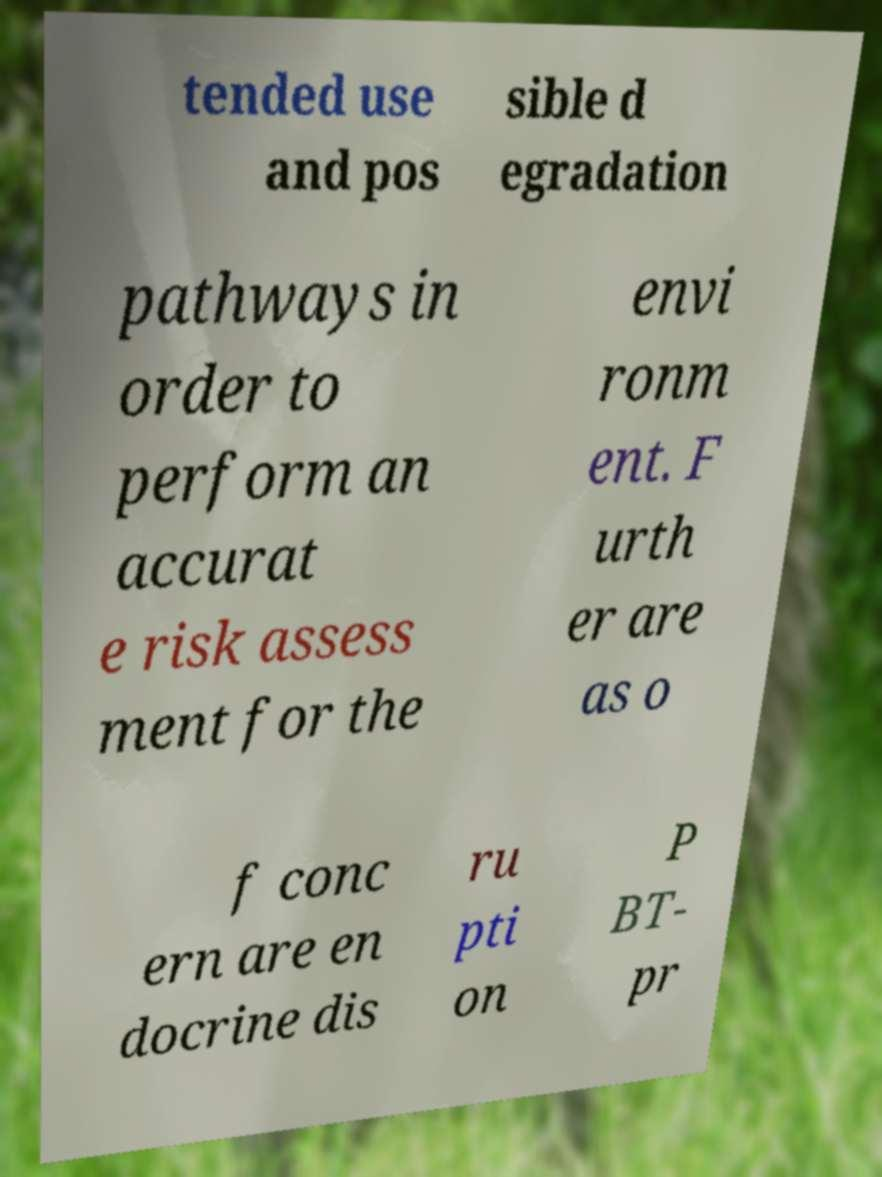Could you assist in decoding the text presented in this image and type it out clearly? tended use and pos sible d egradation pathways in order to perform an accurat e risk assess ment for the envi ronm ent. F urth er are as o f conc ern are en docrine dis ru pti on P BT- pr 